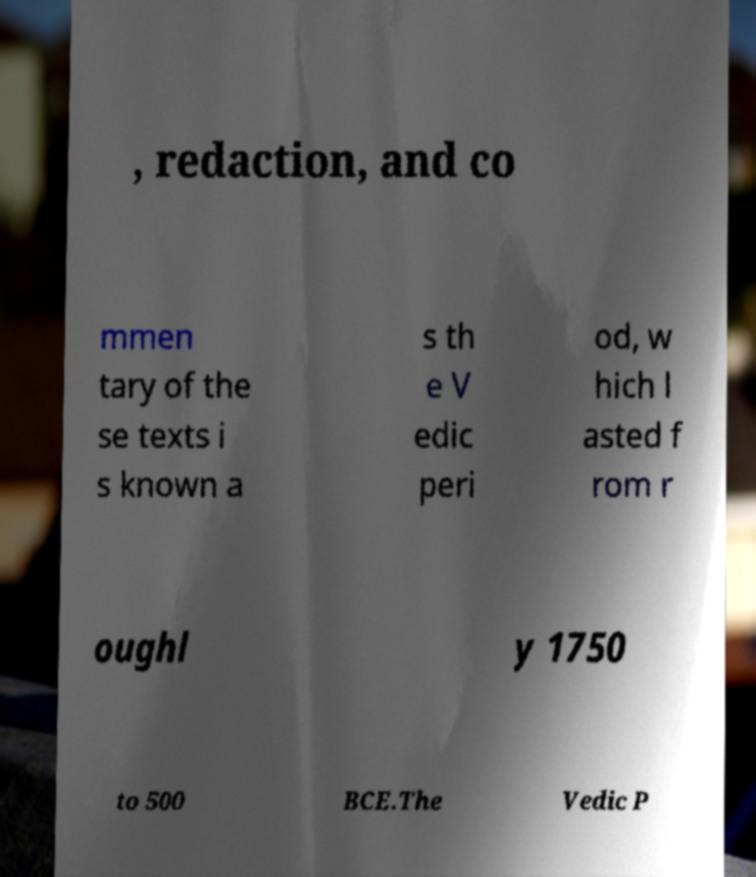Please identify and transcribe the text found in this image. , redaction, and co mmen tary of the se texts i s known a s th e V edic peri od, w hich l asted f rom r oughl y 1750 to 500 BCE.The Vedic P 